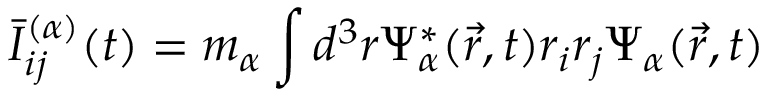<formula> <loc_0><loc_0><loc_500><loc_500>\bar { I } _ { i j } ^ { ( \alpha ) } ( t ) = m _ { \alpha } \int d ^ { 3 } r \Psi _ { \alpha } ^ { * } ( \vec { r } , t ) r _ { i } r _ { j } \Psi _ { \alpha } ( \vec { r } , t )</formula> 